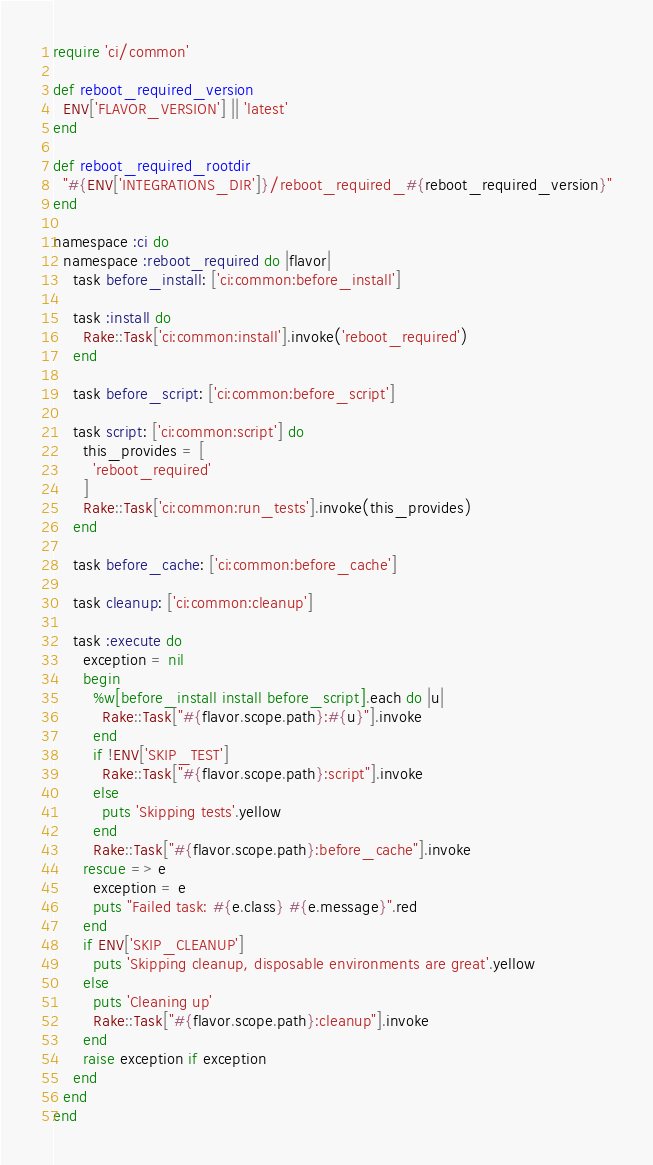Convert code to text. <code><loc_0><loc_0><loc_500><loc_500><_Ruby_>require 'ci/common'

def reboot_required_version
  ENV['FLAVOR_VERSION'] || 'latest'
end

def reboot_required_rootdir
  "#{ENV['INTEGRATIONS_DIR']}/reboot_required_#{reboot_required_version}"
end

namespace :ci do
  namespace :reboot_required do |flavor|
    task before_install: ['ci:common:before_install']

    task :install do
      Rake::Task['ci:common:install'].invoke('reboot_required')
    end

    task before_script: ['ci:common:before_script']

    task script: ['ci:common:script'] do
      this_provides = [
        'reboot_required'
      ]
      Rake::Task['ci:common:run_tests'].invoke(this_provides)
    end

    task before_cache: ['ci:common:before_cache']

    task cleanup: ['ci:common:cleanup']

    task :execute do
      exception = nil
      begin
        %w[before_install install before_script].each do |u|
          Rake::Task["#{flavor.scope.path}:#{u}"].invoke
        end
        if !ENV['SKIP_TEST']
          Rake::Task["#{flavor.scope.path}:script"].invoke
        else
          puts 'Skipping tests'.yellow
        end
        Rake::Task["#{flavor.scope.path}:before_cache"].invoke
      rescue => e
        exception = e
        puts "Failed task: #{e.class} #{e.message}".red
      end
      if ENV['SKIP_CLEANUP']
        puts 'Skipping cleanup, disposable environments are great'.yellow
      else
        puts 'Cleaning up'
        Rake::Task["#{flavor.scope.path}:cleanup"].invoke
      end
      raise exception if exception
    end
  end
end
</code> 